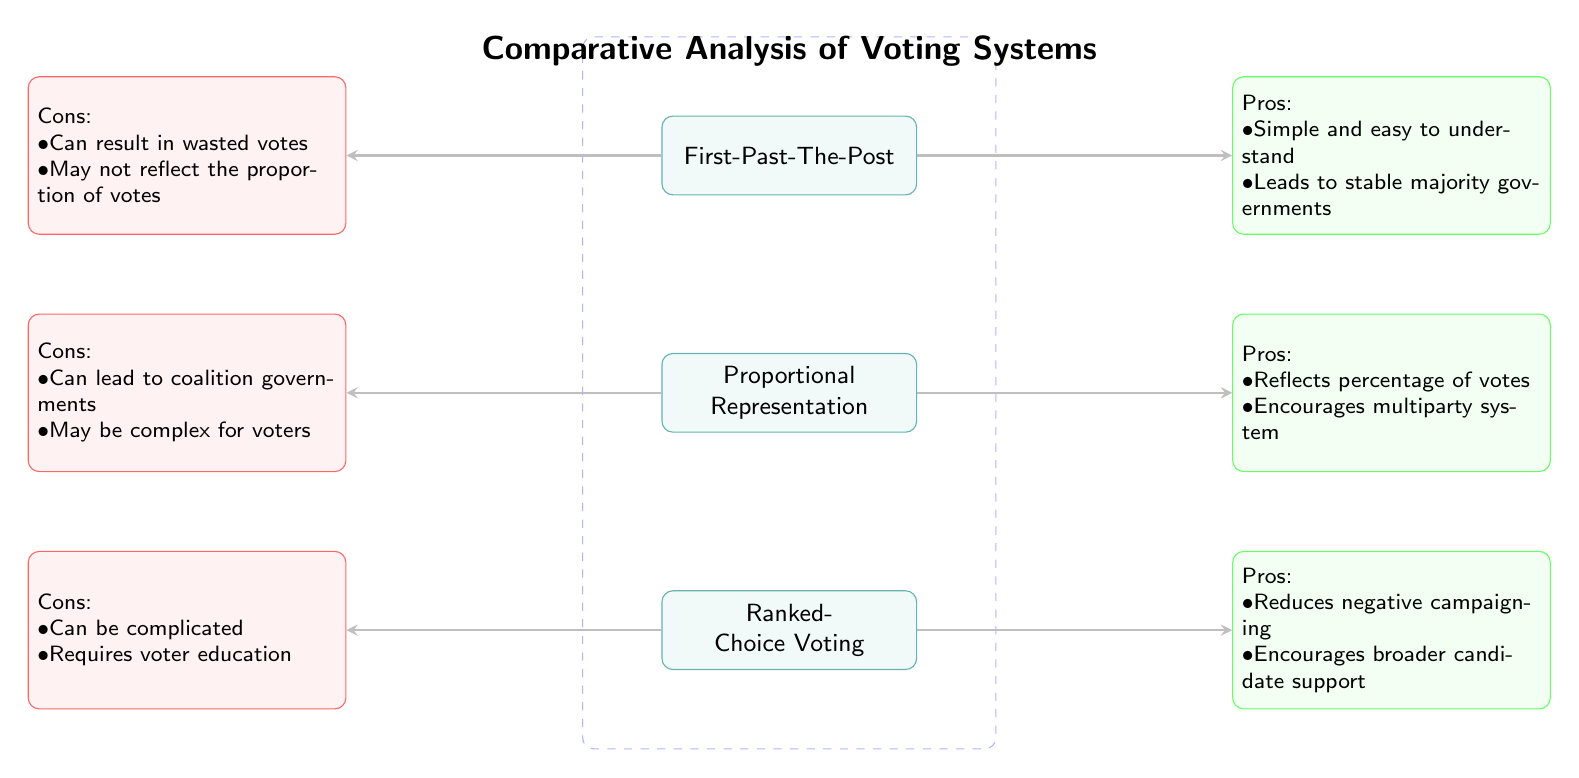What are the three voting systems compared in the diagram? The diagram identifies three voting systems: First-Past-The-Post, Proportional Representation, and Ranked-Choice Voting. Each system is listed as a separate node in the visual structure.
Answer: First-Past-The-Post, Proportional Representation, Ranked-Choice Voting What are the pros of Proportional Representation? The pros listed for Proportional Representation in the diagram include: Reflects percentage of votes and Encourages multiparty system. This information is found in the green-pros node connected to Proportional Representation.
Answer: Reflects percentage of votes, encourages multiparty system How many cons are listed for Ranked-Choice Voting? The diagram shows two cons associated with Ranked-Choice Voting, which are detailed in the red-cons node connected to that system.
Answer: 2 Which voting system has the con related to "wasted votes"? The con about "wasted votes" is associated with the First-Past-The-Post system, as seen in the red-cons node next to it.
Answer: First-Past-The-Post What is the overall theme of the diagram? The overall theme is a comparative analysis of voting systems, which is indicated at the top of the diagram. This theme encompasses the evaluation of pros and cons of different electoral methods.
Answer: Comparative Analysis of Voting Systems What pros are associated with Ranked-Choice Voting? The pros of Ranked-Choice Voting include: Reduces negative campaigning and Encourages broader candidate support, which can be found in the green-pros node corresponding to the Ranked-Choice Voting node.
Answer: Reduces negative campaigning, encourages broader candidate support What are the cons of Proportional Representation? The cons of Proportional Representation are noted as: Can lead to coalition governments and May be complex for voters, found within the red-cons node linked to that voting system.
Answer: Can lead to coalition governments, may be complex for voters Which pros indicate why First-Past-The-Post could be considered favorable? The pros for First-Past-The-Post highlight that it is Simple and easy to understand and leads to stable majority governments, detailed in the green-pros node for that system.
Answer: Simple and easy to understand, leads to stable majority governments 